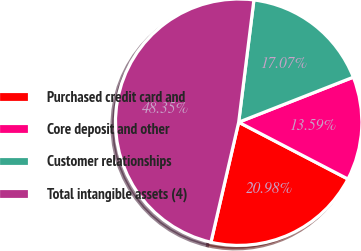Convert chart. <chart><loc_0><loc_0><loc_500><loc_500><pie_chart><fcel>Purchased credit card and<fcel>Core deposit and other<fcel>Customer relationships<fcel>Total intangible assets (4)<nl><fcel>20.98%<fcel>13.59%<fcel>17.07%<fcel>48.35%<nl></chart> 